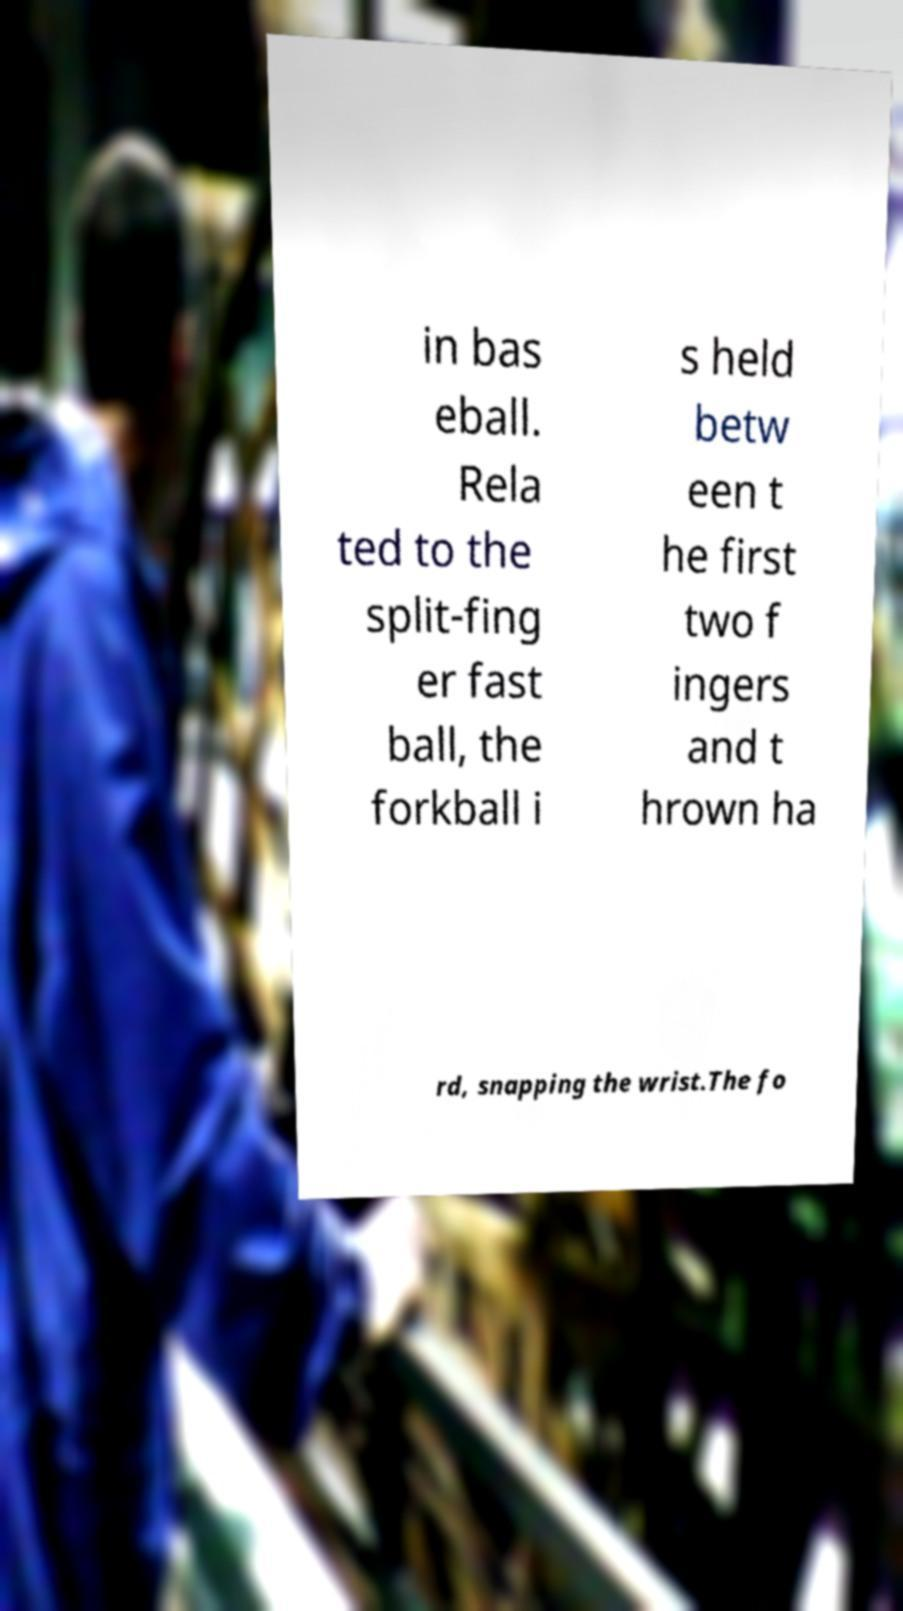Can you accurately transcribe the text from the provided image for me? in bas eball. Rela ted to the split-fing er fast ball, the forkball i s held betw een t he first two f ingers and t hrown ha rd, snapping the wrist.The fo 